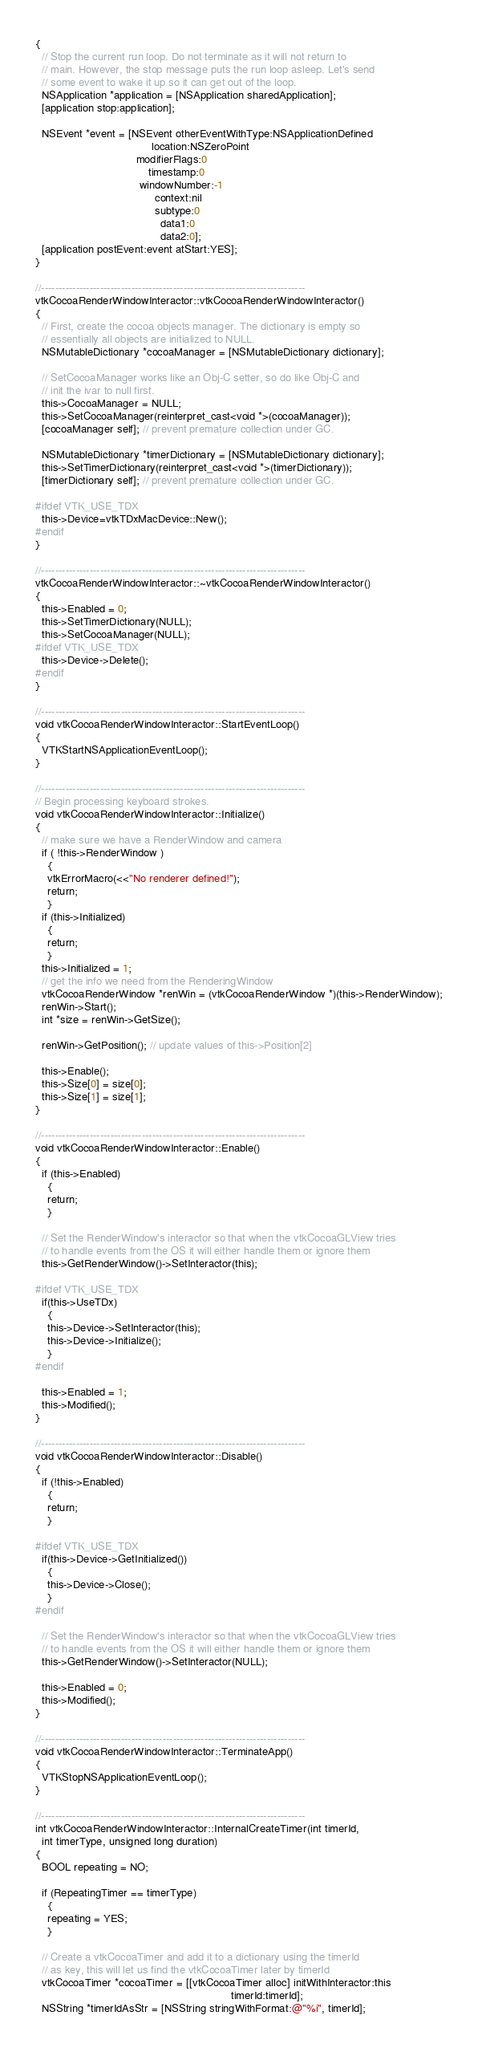<code> <loc_0><loc_0><loc_500><loc_500><_ObjectiveC_>{
  // Stop the current run loop. Do not terminate as it will not return to
  // main. However, the stop message puts the run loop asleep. Let's send
  // some event to wake it up so it can get out of the loop.
  NSApplication *application = [NSApplication sharedApplication];
  [application stop:application];

  NSEvent *event = [NSEvent otherEventWithType:NSApplicationDefined
                                      location:NSZeroPoint
                                 modifierFlags:0
                                     timestamp:0
                                  windowNumber:-1
                                       context:nil
                                       subtype:0
                                         data1:0
                                         data2:0];
  [application postEvent:event atStart:YES];
}

//----------------------------------------------------------------------------
vtkCocoaRenderWindowInteractor::vtkCocoaRenderWindowInteractor()
{
  // First, create the cocoa objects manager. The dictionary is empty so
  // essentially all objects are initialized to NULL.
  NSMutableDictionary *cocoaManager = [NSMutableDictionary dictionary];

  // SetCocoaManager works like an Obj-C setter, so do like Obj-C and
  // init the ivar to null first.
  this->CocoaManager = NULL;
  this->SetCocoaManager(reinterpret_cast<void *>(cocoaManager));
  [cocoaManager self]; // prevent premature collection under GC.

  NSMutableDictionary *timerDictionary = [NSMutableDictionary dictionary];
  this->SetTimerDictionary(reinterpret_cast<void *>(timerDictionary));
  [timerDictionary self]; // prevent premature collection under GC.

#ifdef VTK_USE_TDX
  this->Device=vtkTDxMacDevice::New();
#endif
}

//----------------------------------------------------------------------------
vtkCocoaRenderWindowInteractor::~vtkCocoaRenderWindowInteractor()
{
  this->Enabled = 0;
  this->SetTimerDictionary(NULL);
  this->SetCocoaManager(NULL);
#ifdef VTK_USE_TDX
  this->Device->Delete();
#endif
}

//----------------------------------------------------------------------------
void vtkCocoaRenderWindowInteractor::StartEventLoop()
{
  VTKStartNSApplicationEventLoop();
}

//----------------------------------------------------------------------------
// Begin processing keyboard strokes.
void vtkCocoaRenderWindowInteractor::Initialize()
{
  // make sure we have a RenderWindow and camera
  if ( !this->RenderWindow )
    {
    vtkErrorMacro(<<"No renderer defined!");
    return;
    }
  if (this->Initialized)
    {
    return;
    }
  this->Initialized = 1;
  // get the info we need from the RenderingWindow
  vtkCocoaRenderWindow *renWin = (vtkCocoaRenderWindow *)(this->RenderWindow);
  renWin->Start();
  int *size = renWin->GetSize();

  renWin->GetPosition(); // update values of this->Position[2]

  this->Enable();
  this->Size[0] = size[0];
  this->Size[1] = size[1];
}

//----------------------------------------------------------------------------
void vtkCocoaRenderWindowInteractor::Enable()
{
  if (this->Enabled)
    {
    return;
    }

  // Set the RenderWindow's interactor so that when the vtkCocoaGLView tries
  // to handle events from the OS it will either handle them or ignore them
  this->GetRenderWindow()->SetInteractor(this);

#ifdef VTK_USE_TDX
  if(this->UseTDx)
    {
    this->Device->SetInteractor(this);
    this->Device->Initialize();
    }
#endif

  this->Enabled = 1;
  this->Modified();
}

//----------------------------------------------------------------------------
void vtkCocoaRenderWindowInteractor::Disable()
{
  if (!this->Enabled)
    {
    return;
    }

#ifdef VTK_USE_TDX
  if(this->Device->GetInitialized())
    {
    this->Device->Close();
    }
#endif

  // Set the RenderWindow's interactor so that when the vtkCocoaGLView tries
  // to handle events from the OS it will either handle them or ignore them
  this->GetRenderWindow()->SetInteractor(NULL);

  this->Enabled = 0;
  this->Modified();
}

//----------------------------------------------------------------------------
void vtkCocoaRenderWindowInteractor::TerminateApp()
{
  VTKStopNSApplicationEventLoop();
}

//----------------------------------------------------------------------------
int vtkCocoaRenderWindowInteractor::InternalCreateTimer(int timerId,
  int timerType, unsigned long duration)
{
  BOOL repeating = NO;

  if (RepeatingTimer == timerType)
    {
    repeating = YES;
    }

  // Create a vtkCocoaTimer and add it to a dictionary using the timerId
  // as key, this will let us find the vtkCocoaTimer later by timerId
  vtkCocoaTimer *cocoaTimer = [[vtkCocoaTimer alloc] initWithInteractor:this
                                                                timerId:timerId];
  NSString *timerIdAsStr = [NSString stringWithFormat:@"%i", timerId];</code> 